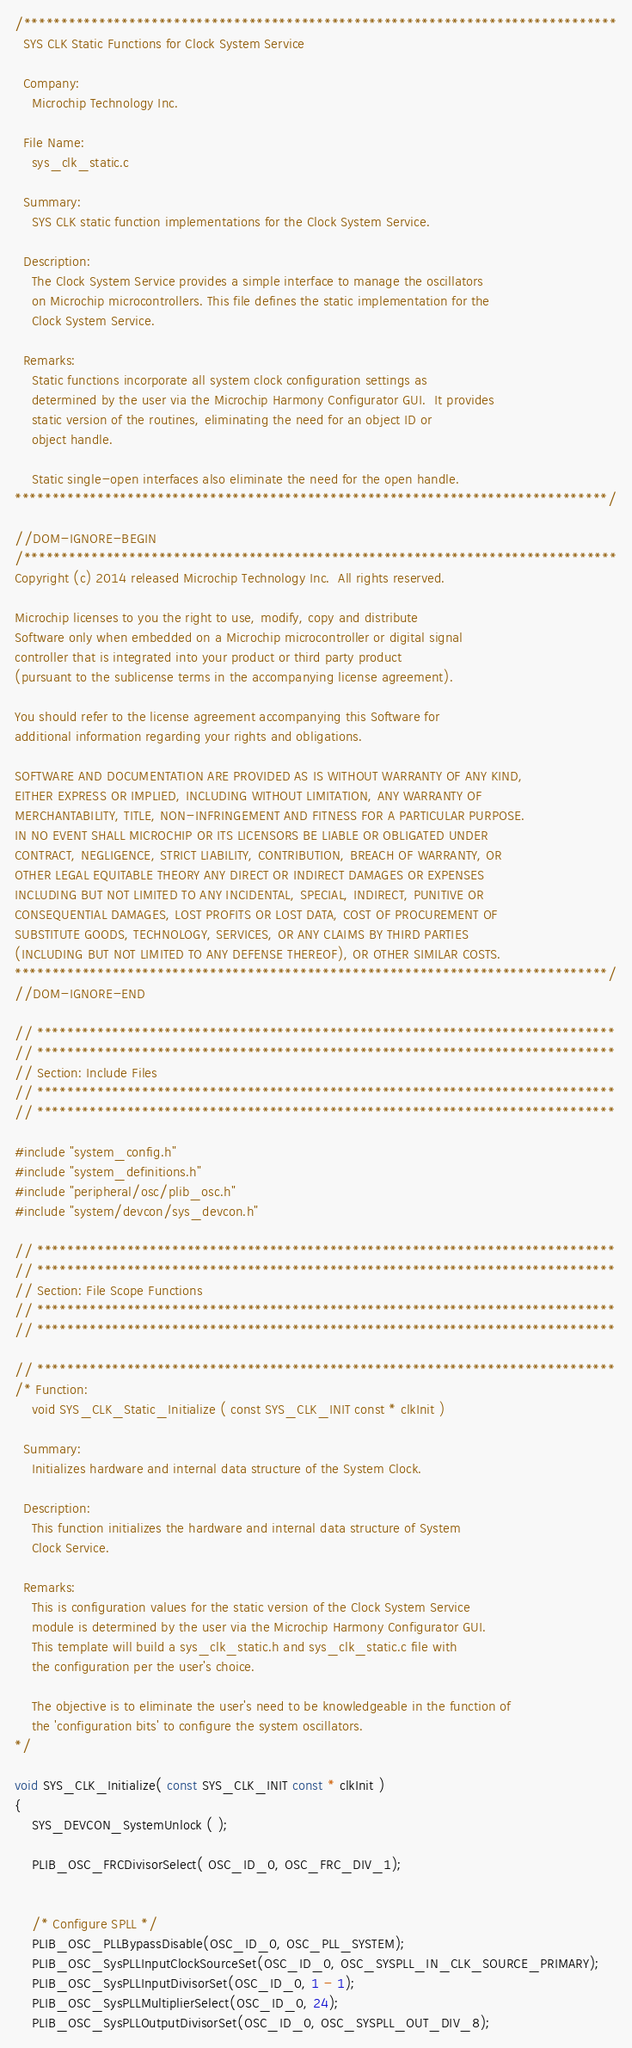Convert code to text. <code><loc_0><loc_0><loc_500><loc_500><_C_>/*******************************************************************************
  SYS CLK Static Functions for Clock System Service

  Company:
    Microchip Technology Inc.

  File Name:
    sys_clk_static.c

  Summary:
    SYS CLK static function implementations for the Clock System Service.

  Description:
    The Clock System Service provides a simple interface to manage the oscillators
    on Microchip microcontrollers. This file defines the static implementation for the 
    Clock System Service.
    
  Remarks:
    Static functions incorporate all system clock configuration settings as
    determined by the user via the Microchip Harmony Configurator GUI.  It provides 
    static version of the routines, eliminating the need for an object ID or 
    object handle.
    
    Static single-open interfaces also eliminate the need for the open handle.
*******************************************************************************/

//DOM-IGNORE-BEGIN
/*******************************************************************************
Copyright (c) 2014 released Microchip Technology Inc.  All rights reserved.

Microchip licenses to you the right to use, modify, copy and distribute
Software only when embedded on a Microchip microcontroller or digital signal
controller that is integrated into your product or third party product
(pursuant to the sublicense terms in the accompanying license agreement).

You should refer to the license agreement accompanying this Software for
additional information regarding your rights and obligations.

SOFTWARE AND DOCUMENTATION ARE PROVIDED AS IS WITHOUT WARRANTY OF ANY KIND,
EITHER EXPRESS OR IMPLIED, INCLUDING WITHOUT LIMITATION, ANY WARRANTY OF
MERCHANTABILITY, TITLE, NON-INFRINGEMENT AND FITNESS FOR A PARTICULAR PURPOSE.
IN NO EVENT SHALL MICROCHIP OR ITS LICENSORS BE LIABLE OR OBLIGATED UNDER
CONTRACT, NEGLIGENCE, STRICT LIABILITY, CONTRIBUTION, BREACH OF WARRANTY, OR
OTHER LEGAL EQUITABLE THEORY ANY DIRECT OR INDIRECT DAMAGES OR EXPENSES
INCLUDING BUT NOT LIMITED TO ANY INCIDENTAL, SPECIAL, INDIRECT, PUNITIVE OR
CONSEQUENTIAL DAMAGES, LOST PROFITS OR LOST DATA, COST OF PROCUREMENT OF
SUBSTITUTE GOODS, TECHNOLOGY, SERVICES, OR ANY CLAIMS BY THIRD PARTIES
(INCLUDING BUT NOT LIMITED TO ANY DEFENSE THEREOF), OR OTHER SIMILAR COSTS.
*******************************************************************************/
//DOM-IGNORE-END

// *****************************************************************************
// *****************************************************************************
// Section: Include Files
// *****************************************************************************
// *****************************************************************************

#include "system_config.h"
#include "system_definitions.h"
#include "peripheral/osc/plib_osc.h"
#include "system/devcon/sys_devcon.h"

// *****************************************************************************
// *****************************************************************************
// Section: File Scope Functions
// *****************************************************************************
// *****************************************************************************

// *****************************************************************************
/* Function:
    void SYS_CLK_Static_Initialize ( const SYS_CLK_INIT const * clkInit )

  Summary:
    Initializes hardware and internal data structure of the System Clock.

  Description:
    This function initializes the hardware and internal data structure of System
    Clock Service.

  Remarks:
    This is configuration values for the static version of the Clock System Service 
    module is determined by the user via the Microchip Harmony Configurator GUI.
    This template will build a sys_clk_static.h and sys_clk_static.c file with 
    the configuration per the user's choice.

    The objective is to eliminate the user's need to be knowledgeable in the function of
    the 'configuration bits' to configure the system oscillators. 
*/

void SYS_CLK_Initialize( const SYS_CLK_INIT const * clkInit )
{
    SYS_DEVCON_SystemUnlock ( );
    
    PLIB_OSC_FRCDivisorSelect( OSC_ID_0, OSC_FRC_DIV_1);


	/* Configure SPLL */
	PLIB_OSC_PLLBypassDisable(OSC_ID_0, OSC_PLL_SYSTEM);
	PLIB_OSC_SysPLLInputClockSourceSet(OSC_ID_0, OSC_SYSPLL_IN_CLK_SOURCE_PRIMARY);
	PLIB_OSC_SysPLLInputDivisorSet(OSC_ID_0, 1 - 1);
	PLIB_OSC_SysPLLMultiplierSelect(OSC_ID_0, 24);
	PLIB_OSC_SysPLLOutputDivisorSet(OSC_ID_0, OSC_SYSPLL_OUT_DIV_8);</code> 